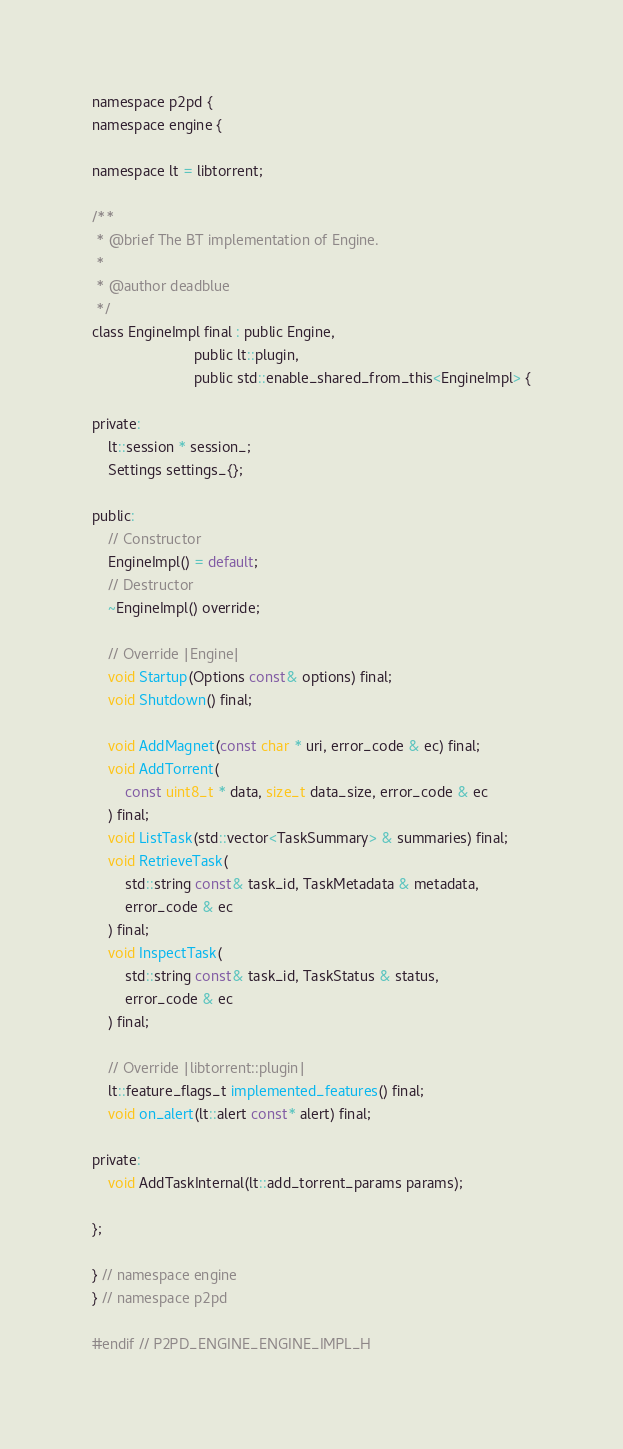<code> <loc_0><loc_0><loc_500><loc_500><_C_>namespace p2pd {
namespace engine {

namespace lt = libtorrent;

/**
 * @brief The BT implementation of Engine.
 * 
 * @author deadblue
 */
class EngineImpl final : public Engine, 
                         public lt::plugin, 
                         public std::enable_shared_from_this<EngineImpl> {

private:
    lt::session * session_;
    Settings settings_{};

public:
    // Constructor
    EngineImpl() = default;
    // Destructor
    ~EngineImpl() override;

    // Override |Engine|
    void Startup(Options const& options) final;
    void Shutdown() final;

    void AddMagnet(const char * uri, error_code & ec) final;
    void AddTorrent(
        const uint8_t * data, size_t data_size, error_code & ec
    ) final;
    void ListTask(std::vector<TaskSummary> & summaries) final;
    void RetrieveTask(
        std::string const& task_id, TaskMetadata & metadata, 
        error_code & ec
    ) final;
    void InspectTask(
        std::string const& task_id, TaskStatus & status, 
        error_code & ec
    ) final;

    // Override |libtorrent::plugin|
    lt::feature_flags_t implemented_features() final;
    void on_alert(lt::alert const* alert) final;

private:
    void AddTaskInternal(lt::add_torrent_params params);

};

} // namespace engine
} // namespace p2pd

#endif // P2PD_ENGINE_ENGINE_IMPL_H
</code> 